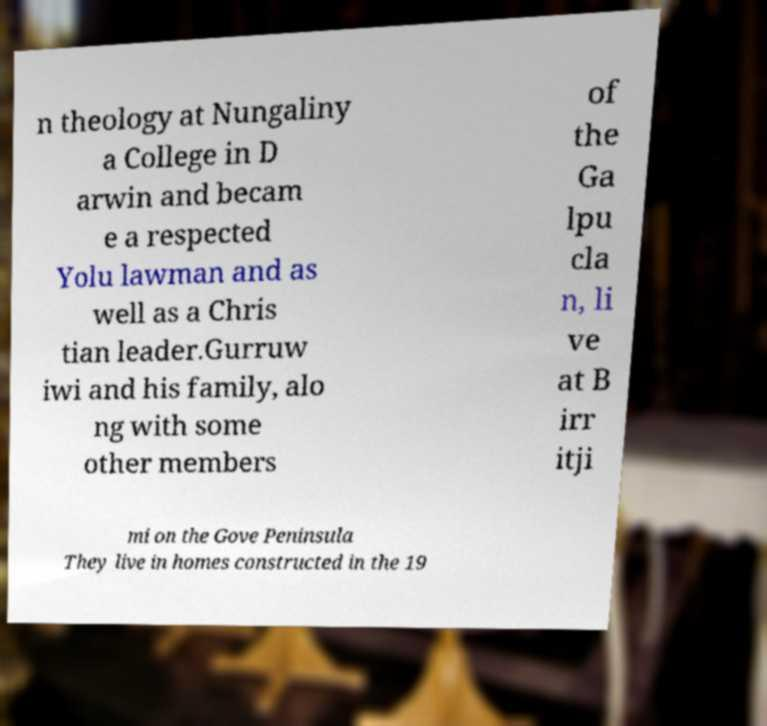Can you accurately transcribe the text from the provided image for me? n theology at Nungaliny a College in D arwin and becam e a respected Yolu lawman and as well as a Chris tian leader.Gurruw iwi and his family, alo ng with some other members of the Ga lpu cla n, li ve at B irr itji mi on the Gove Peninsula They live in homes constructed in the 19 